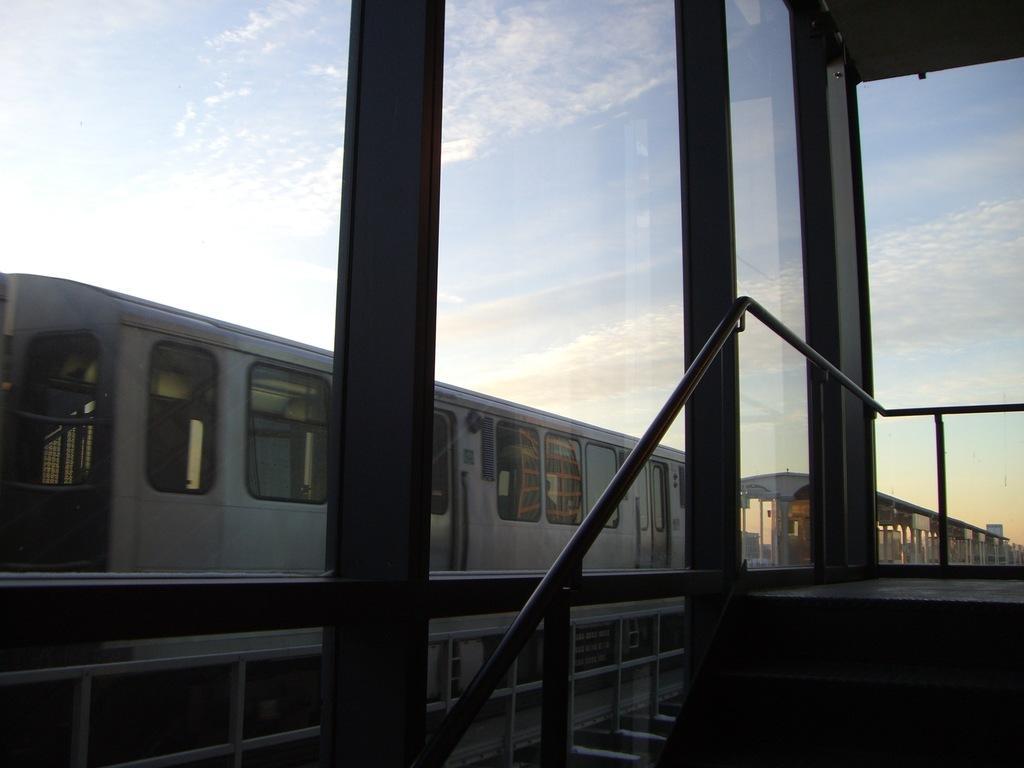Could you give a brief overview of what you see in this image? This is completely an outdoor picture. I guess the picture has been taken from a compartment. At the top of the picture we can see clear sky with clouds. This is a train. 